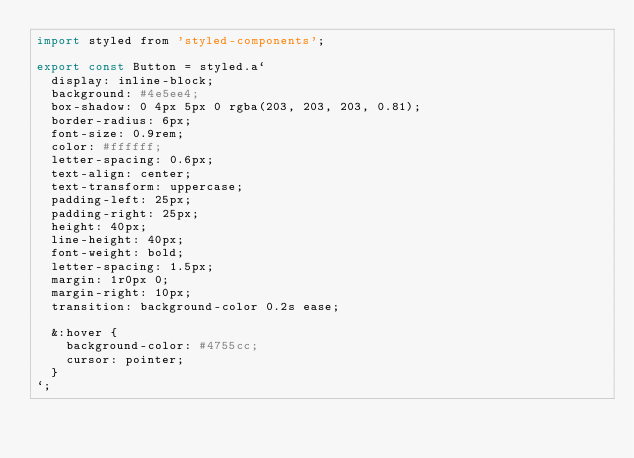Convert code to text. <code><loc_0><loc_0><loc_500><loc_500><_JavaScript_>import styled from 'styled-components';

export const Button = styled.a`
  display: inline-block;
  background: #4e5ee4;
  box-shadow: 0 4px 5px 0 rgba(203, 203, 203, 0.81);
  border-radius: 6px;
  font-size: 0.9rem;
  color: #ffffff;
  letter-spacing: 0.6px;
  text-align: center;
  text-transform: uppercase;
  padding-left: 25px;
  padding-right: 25px;
  height: 40px;
  line-height: 40px;
  font-weight: bold;
  letter-spacing: 1.5px;
  margin: 1r0px 0;
  margin-right: 10px;
  transition: background-color 0.2s ease;

  &:hover {
    background-color: #4755cc;
    cursor: pointer;
  }
`;
</code> 